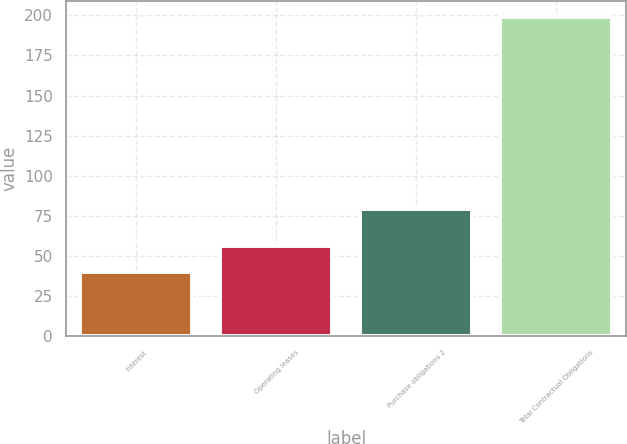<chart> <loc_0><loc_0><loc_500><loc_500><bar_chart><fcel>Interest<fcel>Operating leases<fcel>Purchase obligations 2<fcel>Total Contractual Obligations<nl><fcel>40.1<fcel>56.01<fcel>79.4<fcel>199.2<nl></chart> 